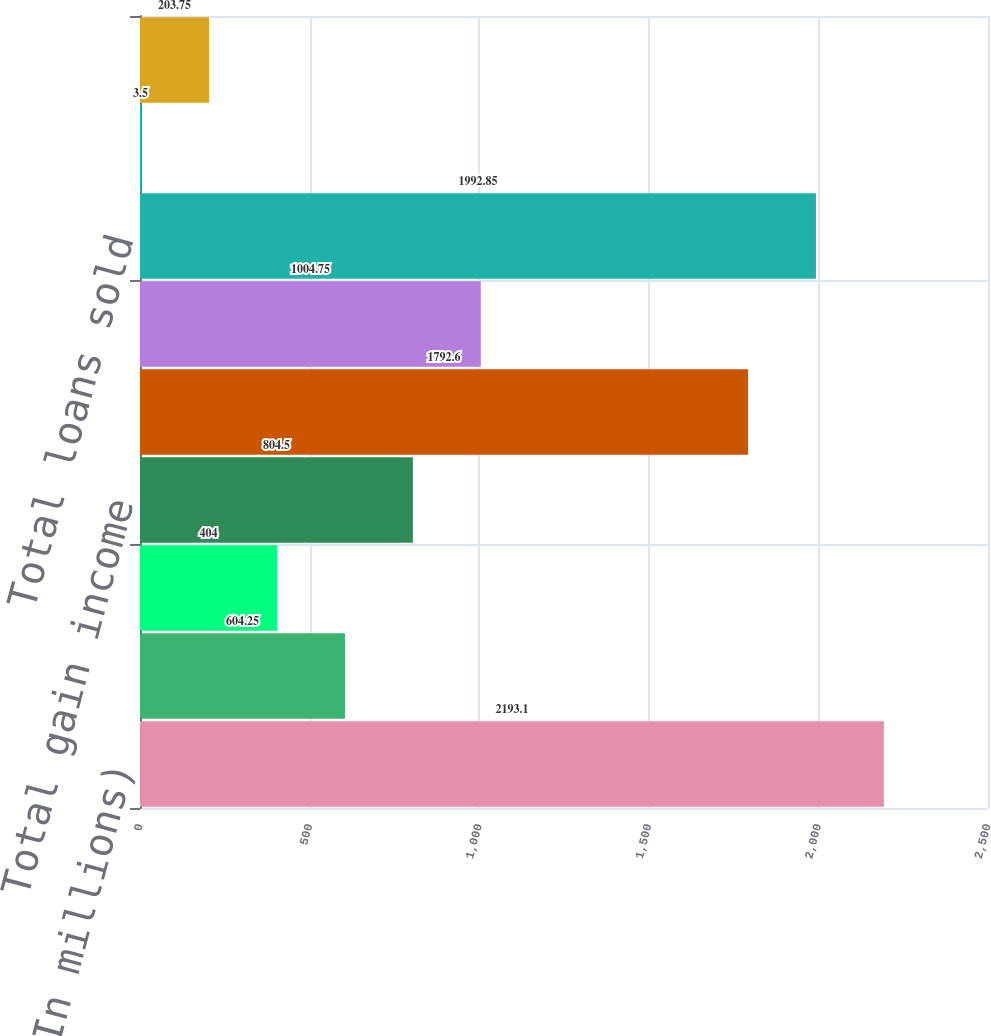<chart> <loc_0><loc_0><loc_500><loc_500><bar_chart><fcel>(In millions)<fcel>Gains on sales of loans<fcel>Other gain income<fcel>Total gain income<fcel>Loans originated and sold<fcel>Receivables repurchased from<fcel>Total loans sold<fcel>Gain percentage on loans<fcel>Total gain income as a<nl><fcel>2193.1<fcel>604.25<fcel>404<fcel>804.5<fcel>1792.6<fcel>1004.75<fcel>1992.85<fcel>3.5<fcel>203.75<nl></chart> 